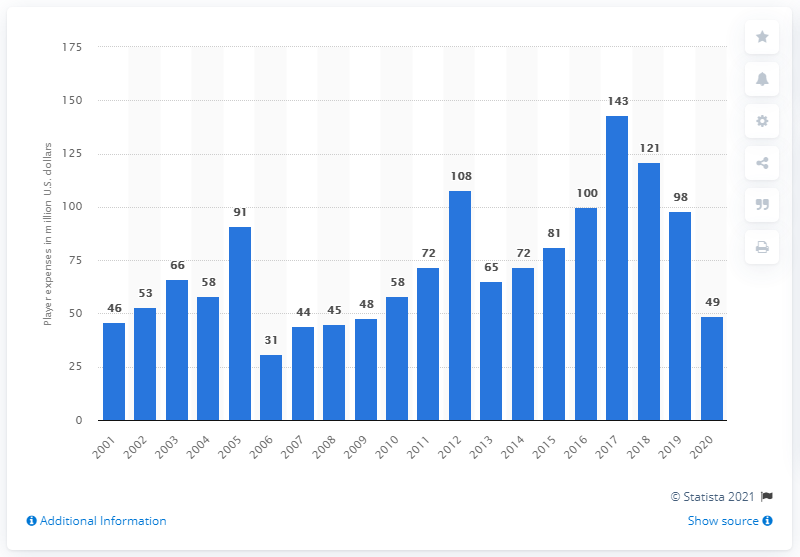Outline some significant characteristics in this image. The payroll of the Miami Marlins in 2020 was $49 million. 